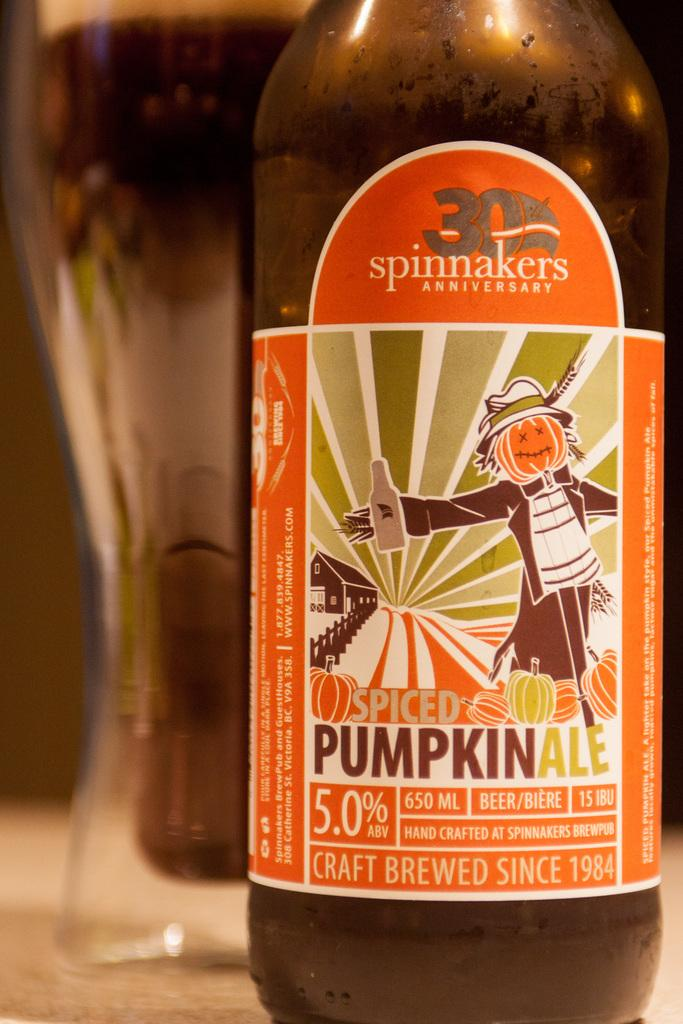<image>
Share a concise interpretation of the image provided. An orange bottle of Spiced pumpkin ale with a scarecrow on it 